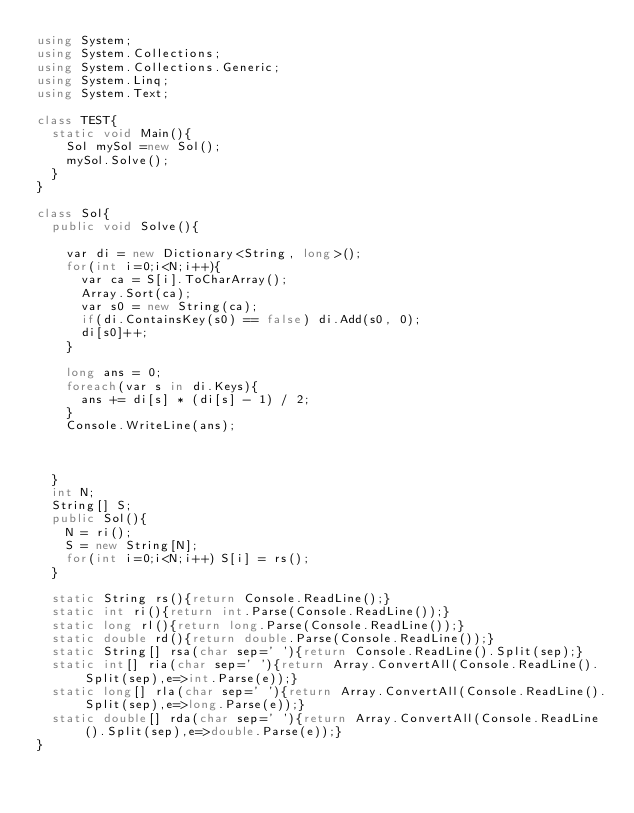<code> <loc_0><loc_0><loc_500><loc_500><_C#_>using System;
using System.Collections;
using System.Collections.Generic;
using System.Linq;
using System.Text;

class TEST{
	static void Main(){
		Sol mySol =new Sol();
		mySol.Solve();
	}
}

class Sol{
	public void Solve(){
		
		var di = new Dictionary<String, long>();
		for(int i=0;i<N;i++){
			var ca = S[i].ToCharArray();
			Array.Sort(ca);
			var s0 = new String(ca);
			if(di.ContainsKey(s0) == false) di.Add(s0, 0);
			di[s0]++;
		}
		
		long ans = 0;
		foreach(var s in di.Keys){
			ans += di[s] * (di[s] - 1) / 2;
		}
		Console.WriteLine(ans);
		
		
		
	}
	int N;
	String[] S;
	public Sol(){
		N = ri();
		S = new String[N];
		for(int i=0;i<N;i++) S[i] = rs();
	}

	static String rs(){return Console.ReadLine();}
	static int ri(){return int.Parse(Console.ReadLine());}
	static long rl(){return long.Parse(Console.ReadLine());}
	static double rd(){return double.Parse(Console.ReadLine());}
	static String[] rsa(char sep=' '){return Console.ReadLine().Split(sep);}
	static int[] ria(char sep=' '){return Array.ConvertAll(Console.ReadLine().Split(sep),e=>int.Parse(e));}
	static long[] rla(char sep=' '){return Array.ConvertAll(Console.ReadLine().Split(sep),e=>long.Parse(e));}
	static double[] rda(char sep=' '){return Array.ConvertAll(Console.ReadLine().Split(sep),e=>double.Parse(e));}
}
</code> 